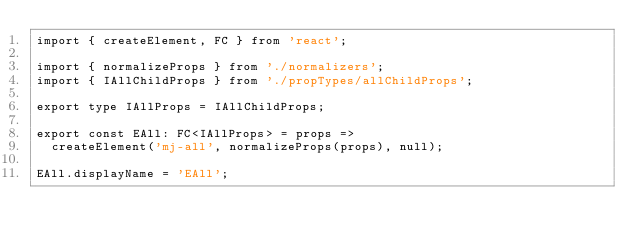Convert code to text. <code><loc_0><loc_0><loc_500><loc_500><_TypeScript_>import { createElement, FC } from 'react';

import { normalizeProps } from './normalizers';
import { IAllChildProps } from './propTypes/allChildProps';

export type IAllProps = IAllChildProps;

export const EAll: FC<IAllProps> = props =>
  createElement('mj-all', normalizeProps(props), null);

EAll.displayName = 'EAll';
</code> 